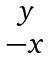<formula> <loc_0><loc_0><loc_500><loc_500>\begin{matrix} y \\ - x \end{matrix}</formula> 